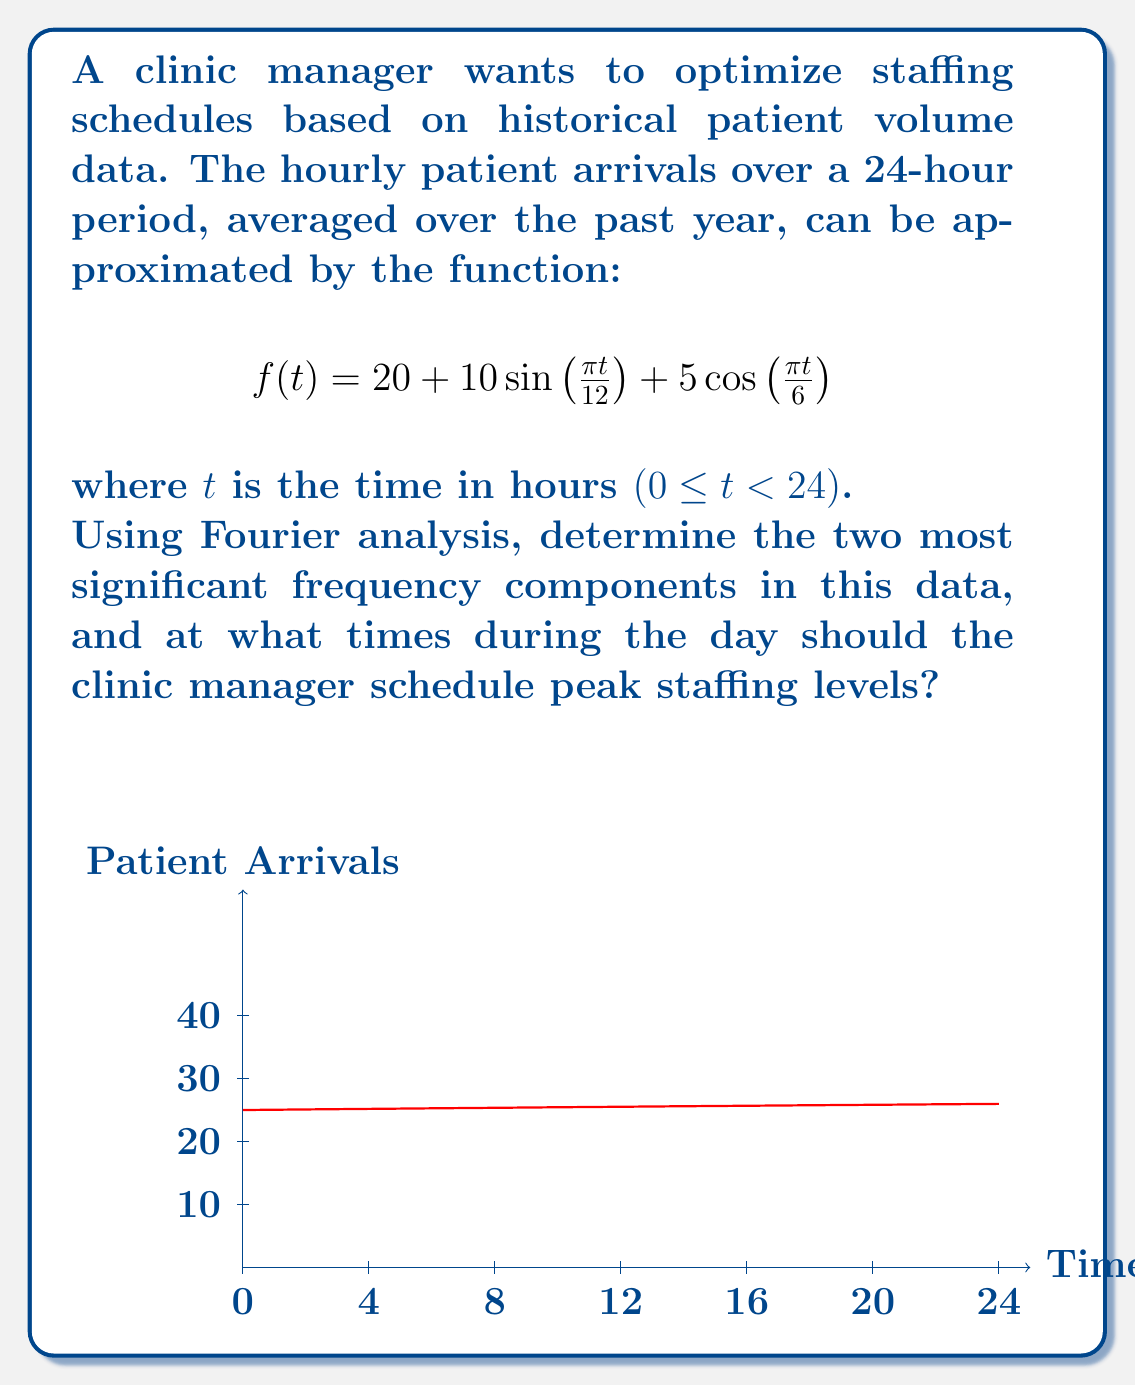Teach me how to tackle this problem. To solve this problem, we'll follow these steps:

1) Identify the frequency components:
   The given function is already in the form of a Fourier series:
   $$f(t) = 20 + 10\sin(\frac{\pi t}{12}) + 5\cos(\frac{\pi t}{6})$$

   We can rewrite this as:
   $$f(t) = A_0 + A_1\sin(\omega_1 t) + A_2\cos(\omega_2 t)$$

   Where:
   $A_0 = 20$ (constant term)
   $A_1 = 10$, $\omega_1 = \frac{\pi}{12}$
   $A_2 = 5$, $\omega_2 = \frac{\pi}{6}$

2) The two most significant frequency components are:
   - $\omega_1 = \frac{\pi}{12}$ (period of 24 hours)
   - $\omega_2 = \frac{\pi}{6}$ (period of 12 hours)

3) To find peak staffing times, we need to find the maxima of the function:
   For the $\sin$ term: $\sin(\frac{\pi t}{12})$ is maximum when $\frac{\pi t}{12} = \frac{\pi}{2}$, i.e., $t = 6$
   For the $\cos$ term: $\cos(\frac{\pi t}{6})$ is maximum when $\frac{\pi t}{6} = 0$, i.e., $t = 0$ or $t = 12$

4) Combining these, we expect peaks at $t = 6$ and $t = 18$ (6 PM) due to the sine term, and additional influence at $t = 0$ (midnight) and $t = 12$ (noon) due to the cosine term.

5) To confirm, we can calculate $f(t)$ at these points:
   $f(6) = 20 + 10 + 0 = 30$
   $f(18) = 20 + 10 + 0 = 30$
   $f(0) = f(24) = 20 + 0 + 5 = 25$
   $f(12) = 20 + 0 + 5 = 25$

Therefore, the clinic manager should schedule peak staffing levels at 6:00 AM and 6:00 PM, with secondary peaks at midnight and noon.
Answer: Peak staffing at 6:00 AM and 6:00 PM; secondary peaks at midnight and noon. 